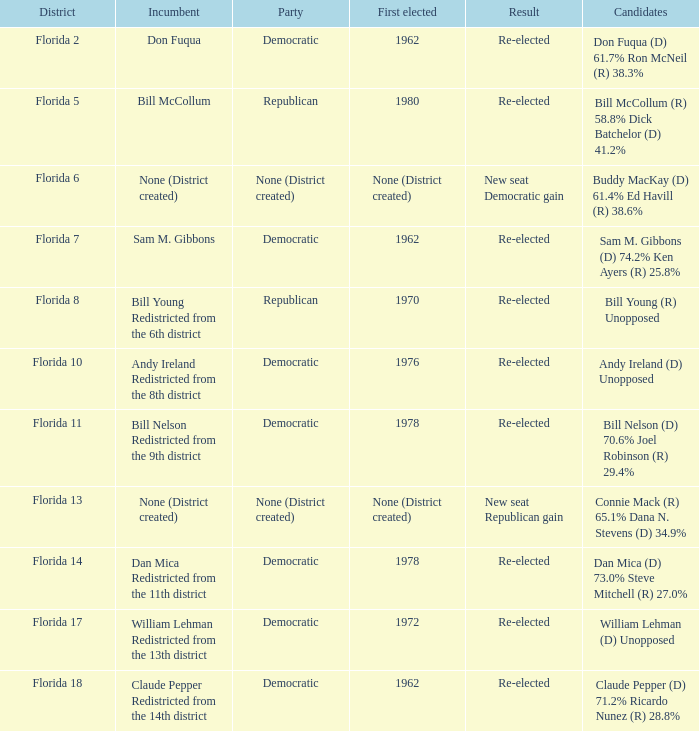Which elected office was the first in the 7th district of florida? 1962.0. 